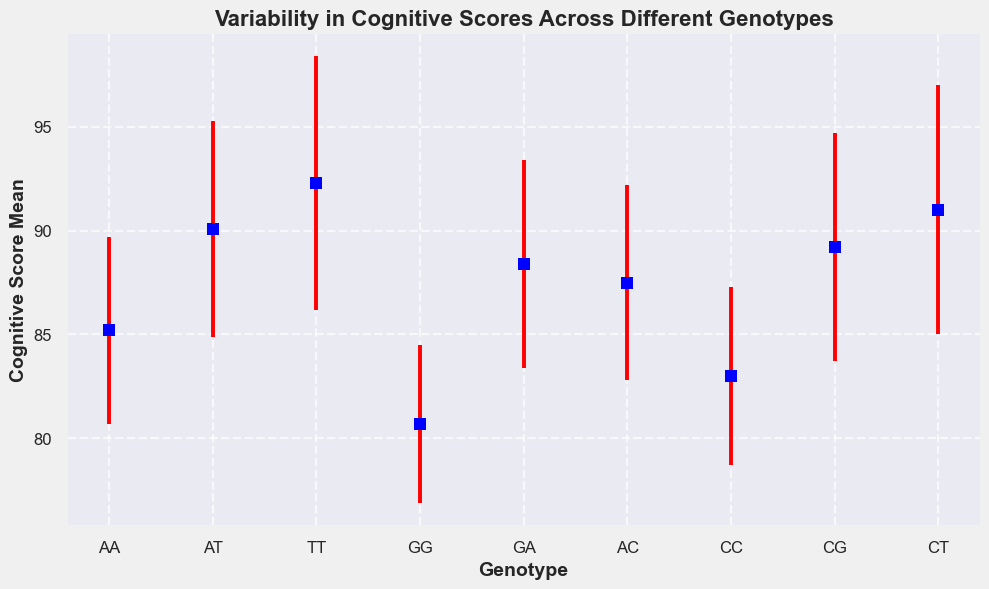What is the mean cognitive score for the AA genotype? To find the mean cognitive score for the AA genotype, look for the point labeled "AA" on the x-axis and identify its position on the y-axis. In the data, the AA genotype has a mean cognitive score of 85.2.
Answer: 85.2 Which genotype has the highest mean cognitive score? To determine the genotype with the highest mean cognitive score, compare the heights of the error bars for each genotype on the y-axis. The highest value on the y-axis corresponds to the TT genotype, which has a mean cognitive score of 92.3.
Answer: TT What is the difference in mean cognitive scores between the TT and GG genotypes? First, find the mean cognitive scores for the TT and GG genotypes, which are 92.3 and 80.7, respectively. Then, subtract the GG score from the TT score: 92.3 - 80.7 = 11.6.
Answer: 11.6 Which genotype has the smallest variability in cognitive scores? Variability is represented by the length of the error bars (standard deviation). The genotype with the shortest error bar has the smallest variability. The GG genotype has the shortest error bar with a standard deviation of 3.8.
Answer: GG What is the combined mean cognitive score of genotypes that start with A (AA, AT, AC)? Identify the mean cognitive scores for AA (85.2), AT (90.1), and AC (87.5). Sum these values: 85.2 + 90.1 + 87.5 = 262.8.
Answer: 262.8 Which genotypes have cognitive scores within one standard deviation of each other? Check each genotype’s mean and standard deviation and compare them to see if the mean cognitive score of one falls within the standard deviation range of another. The genotypes GA (mean = 88.4, stddev = 5.0) and AC (mean = 87.5, stddev = 4.7) fit this criterion because 88.4 ± 5.0 includes 87.5.
Answer: GA and AC 